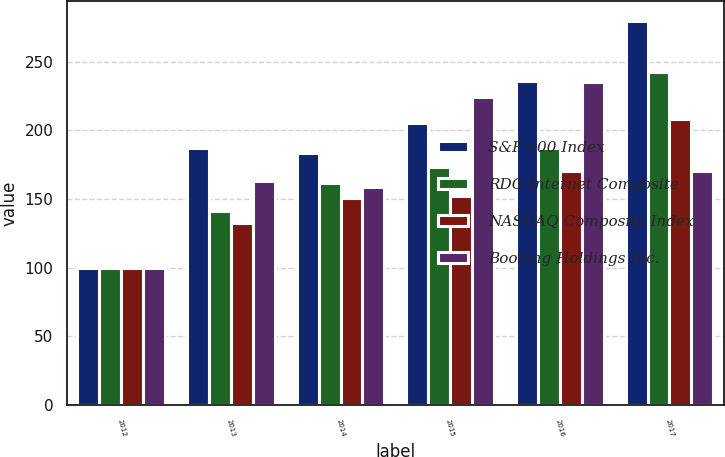<chart> <loc_0><loc_0><loc_500><loc_500><stacked_bar_chart><ecel><fcel>2012<fcel>2013<fcel>2014<fcel>2015<fcel>2016<fcel>2017<nl><fcel>S&P 500 Index<fcel>100<fcel>187.37<fcel>183.79<fcel>205.51<fcel>236.31<fcel>280.1<nl><fcel>RDG Internet Composite<fcel>100<fcel>141.63<fcel>162.09<fcel>173.33<fcel>187.19<fcel>242.29<nl><fcel>NASDAQ Composite Index<fcel>100<fcel>132.39<fcel>150.51<fcel>152.59<fcel>170.84<fcel>208.14<nl><fcel>Booking Holdings Inc.<fcel>100<fcel>163.02<fcel>158.81<fcel>224.05<fcel>235.33<fcel>170.84<nl></chart> 